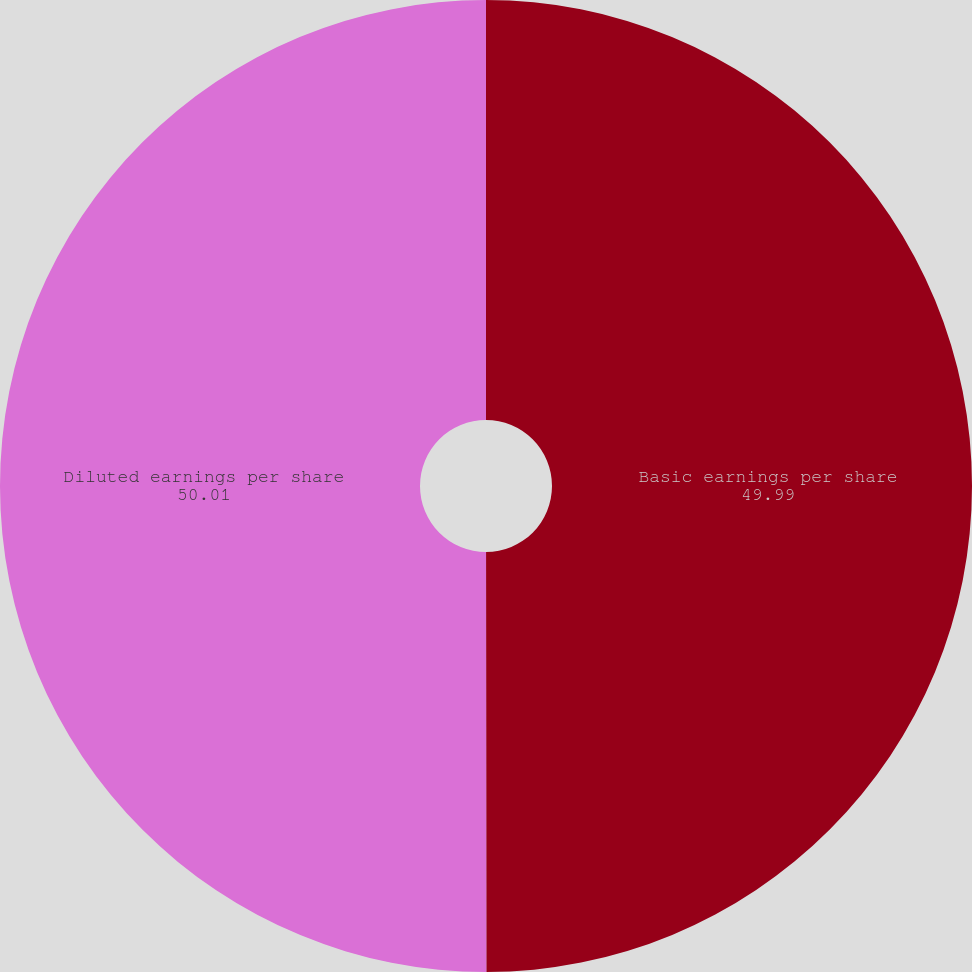Convert chart. <chart><loc_0><loc_0><loc_500><loc_500><pie_chart><fcel>Basic earnings per share<fcel>Diluted earnings per share<nl><fcel>49.99%<fcel>50.01%<nl></chart> 